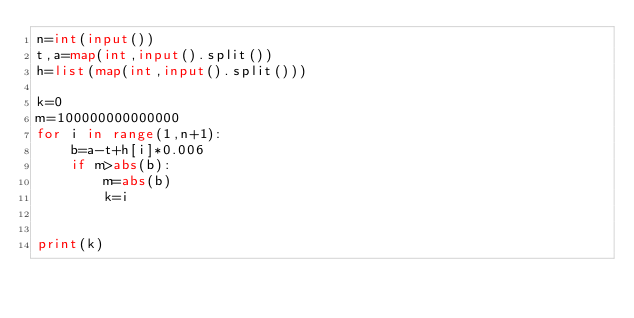<code> <loc_0><loc_0><loc_500><loc_500><_Python_>n=int(input())
t,a=map(int,input().split())
h=list(map(int,input().split()))

k=0
m=100000000000000
for i in range(1,n+1):
    b=a-t+h[i]*0.006
    if m>abs(b):
        m=abs(b)
        k=i


print(k)        
        </code> 